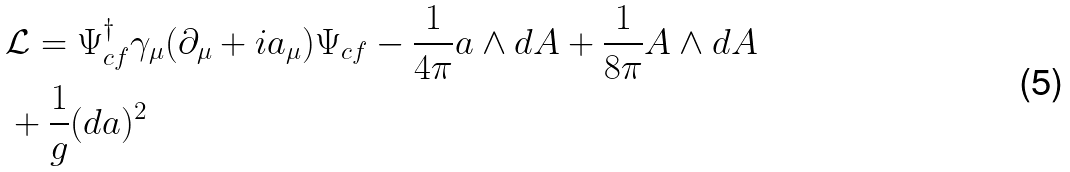Convert formula to latex. <formula><loc_0><loc_0><loc_500><loc_500>& \mathcal { L } = \Psi ^ { \dagger } _ { c f } \gamma _ { \mu } ( \partial _ { \mu } + i a _ { \mu } ) \Psi _ { c f } - \frac { 1 } { 4 \pi } a \wedge d A + \frac { 1 } { 8 \pi } A \wedge d A \\ & + \frac { 1 } { g } ( d a ) ^ { 2 }</formula> 